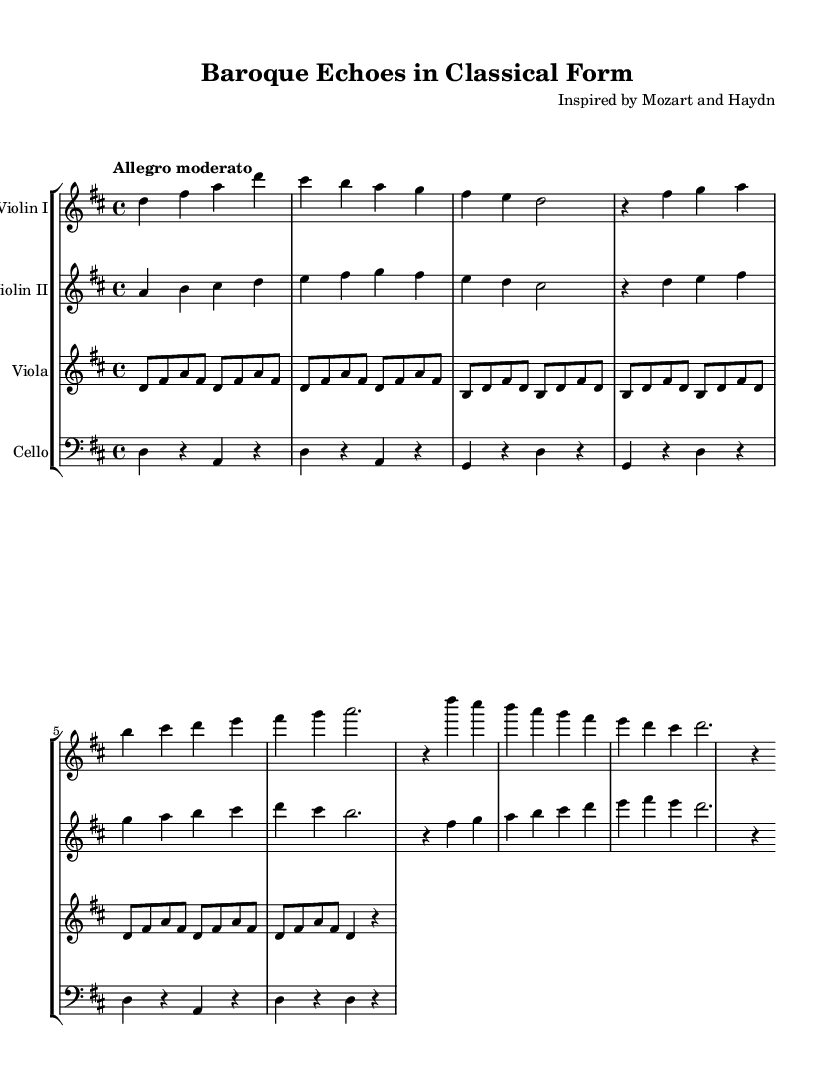What is the key signature of this music? The key signature is D major, which is indicated by two sharps: F sharp and C sharp.
Answer: D major What is the time signature of this music? The time signature is 4/4, which means there are four beats in a measure and the quarter note gets one beat.
Answer: 4/4 What is the tempo marking of this music? The tempo marking indicates "Allegro moderato," which is a moderately fast tempo.
Answer: Allegro moderato How many main sections can be identified in the piece? The music is structured into three main sections: Exposition, Development, and Recapitulation.
Answer: Three What musical texture is primarily featured in Violin II? Violin II primarily features counterpoint, as it plays a complementary melodic line to Violin I.
Answer: Counterpoint In what manner does the viola contribute to the texture of the piece? The viola contributes an Alberti bass pattern, which provides harmonic support and creates a rhythmic foundation.
Answer: Alberti bass What is the duration of the final note in the violin parts during the recapitulation? The final note in the recapitulation for the violin parts is a half note, lasting for two beats.
Answer: Half note 